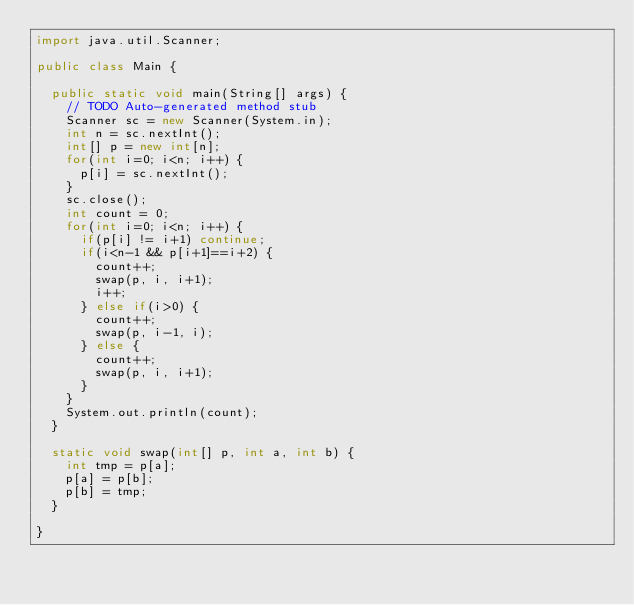<code> <loc_0><loc_0><loc_500><loc_500><_Java_>import java.util.Scanner;

public class Main {

	public static void main(String[] args) {
		// TODO Auto-generated method stub
		Scanner sc = new Scanner(System.in);
		int n = sc.nextInt();
		int[] p = new int[n];
		for(int i=0; i<n; i++) {
			p[i] = sc.nextInt();
		}
		sc.close();
		int count = 0;
		for(int i=0; i<n; i++) {
			if(p[i] != i+1) continue;
			if(i<n-1 && p[i+1]==i+2) {
				count++;
				swap(p, i, i+1);
				i++;
			} else if(i>0) {
				count++;
				swap(p, i-1, i);
			} else {
				count++;
				swap(p, i, i+1);
			}
		} 
		System.out.println(count);
	}
	
	static void swap(int[] p, int a, int b) {
		int tmp = p[a];
		p[a] = p[b];
		p[b] = tmp;
	}

}</code> 